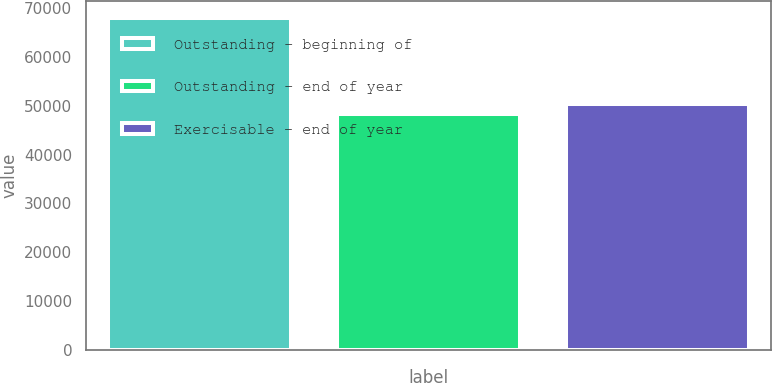Convert chart to OTSL. <chart><loc_0><loc_0><loc_500><loc_500><bar_chart><fcel>Outstanding - beginning of<fcel>Outstanding - end of year<fcel>Exercisable - end of year<nl><fcel>68071<fcel>48446<fcel>50408.5<nl></chart> 